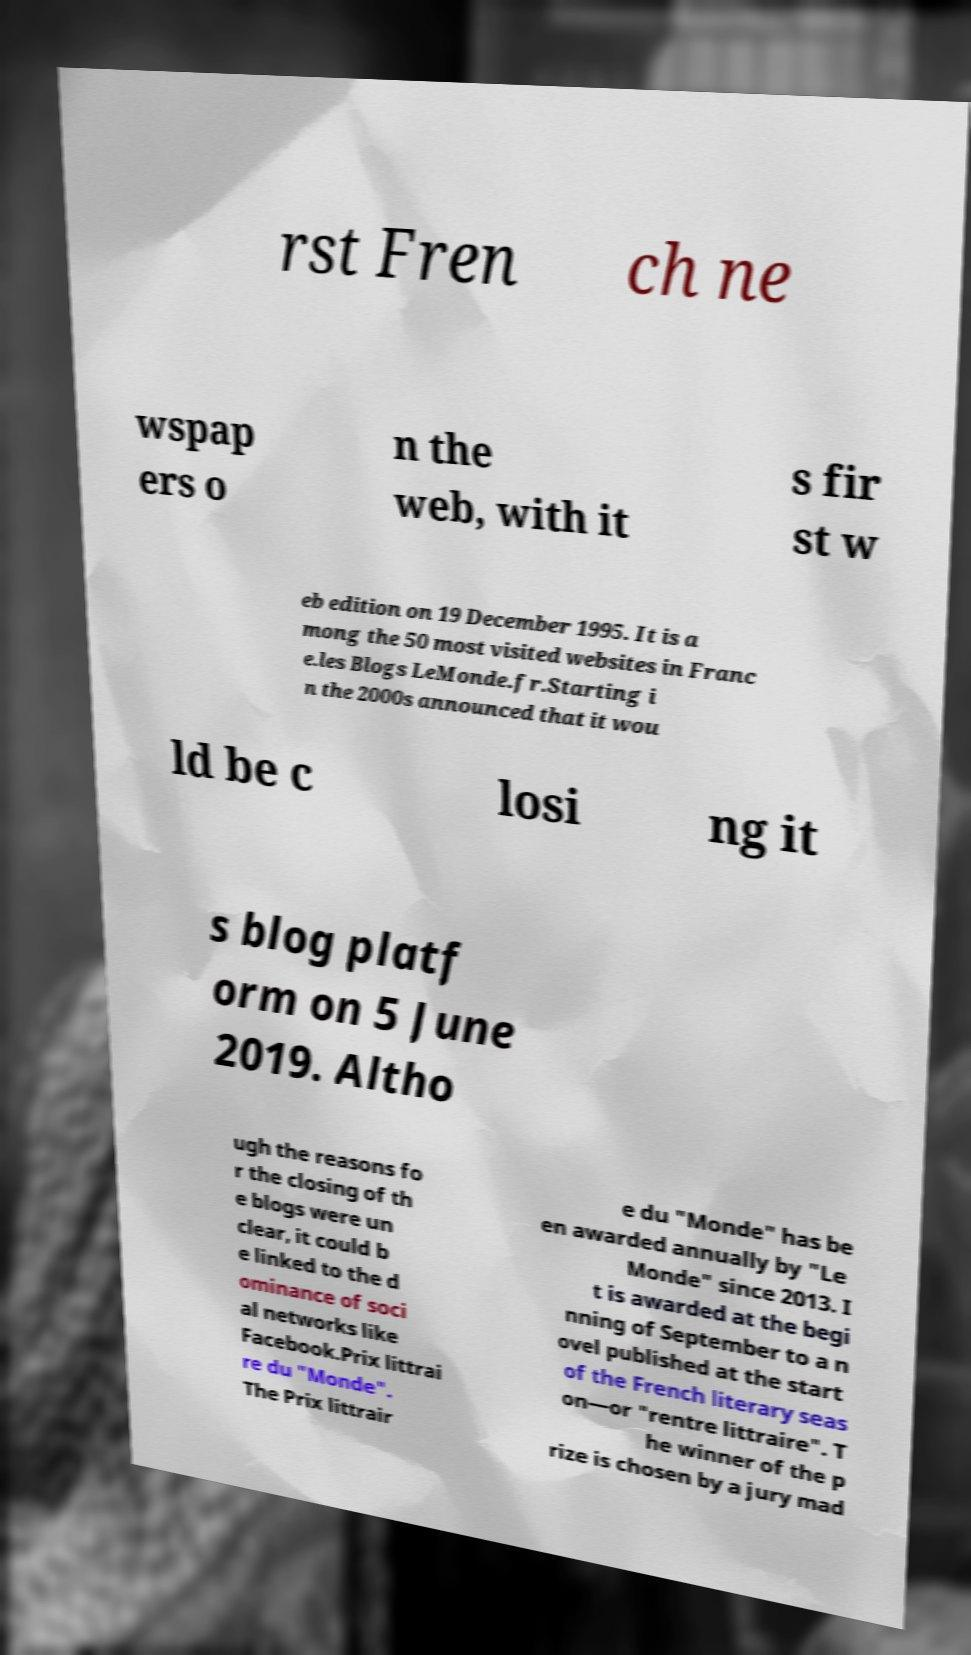There's text embedded in this image that I need extracted. Can you transcribe it verbatim? rst Fren ch ne wspap ers o n the web, with it s fir st w eb edition on 19 December 1995. It is a mong the 50 most visited websites in Franc e.les Blogs LeMonde.fr.Starting i n the 2000s announced that it wou ld be c losi ng it s blog platf orm on 5 June 2019. Altho ugh the reasons fo r the closing of th e blogs were un clear, it could b e linked to the d ominance of soci al networks like Facebook.Prix littrai re du "Monde". The Prix littrair e du "Monde" has be en awarded annually by "Le Monde" since 2013. I t is awarded at the begi nning of September to a n ovel published at the start of the French literary seas on—or "rentre littraire". T he winner of the p rize is chosen by a jury mad 